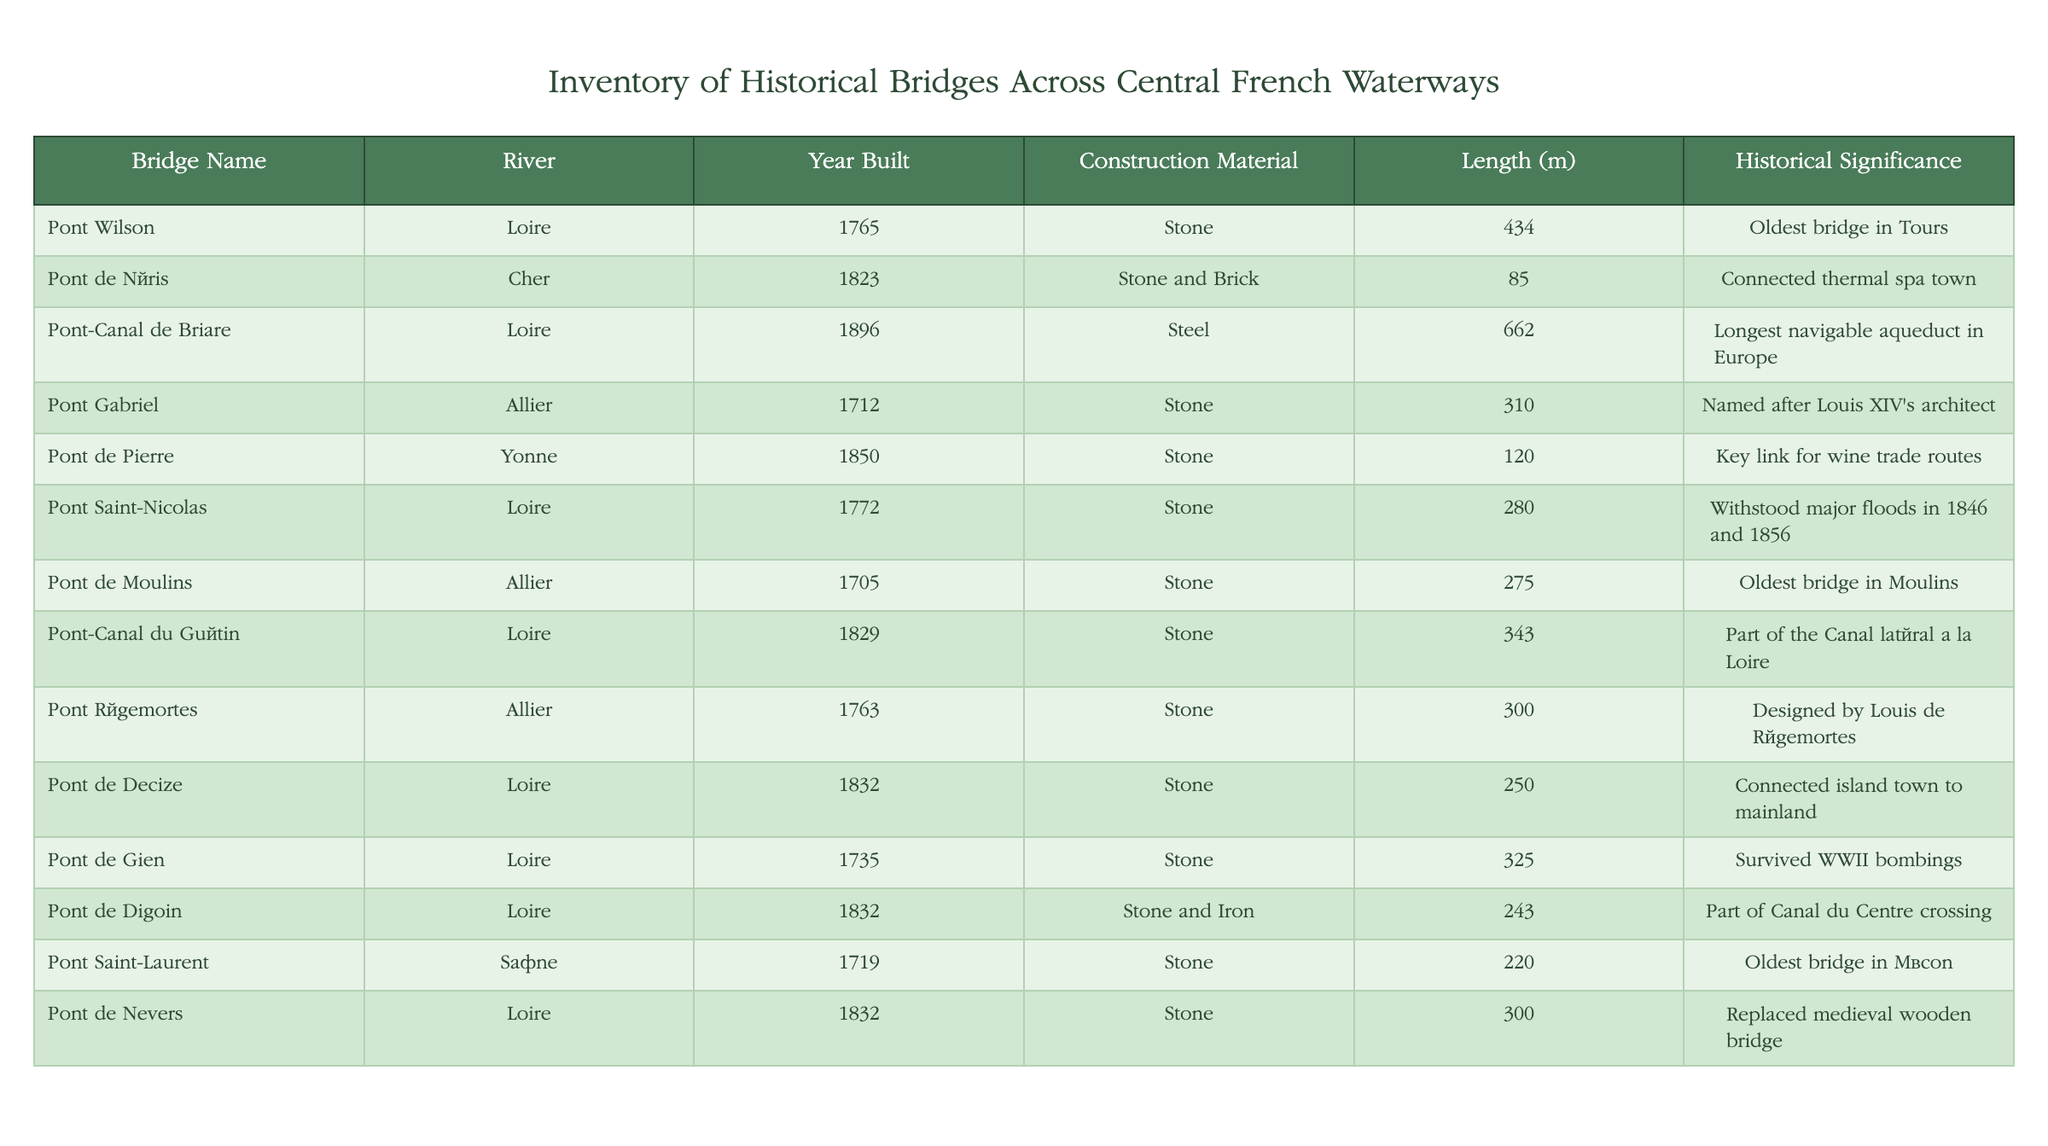What is the longest bridge listed in the inventory? The "Pont-Canal de Briare" is listed in the table with a length of 662 meters, which is the highest value among all bridges.
Answer: Pont-Canal de Briare Which bridge was built in the year 1829? The table shows that "Pont-Canal du Guétin" was constructed in 1829, specifically mentioned in the third column of the inventory.
Answer: Pont-Canal du Guétin Is there a bridge made of steel? The "Pont-Canal de Briare" is noted as being made of steel, confirming that there is indeed a bridge constructed with this material.
Answer: Yes What is the average length of the bridges that are made of stone? We gather the lengths of the stone bridges: 434, 85, 310, 275, 300, 325, 300 (total 1960), and divide by the number of stone bridges, which is 8. The average length is 1960/8 = 245 meters.
Answer: 245 How many bridges were built after 1800? The bridges built after 1800 are "Pont de Néris" (1823), "Pont-Canal du Guétin" (1829), "Pont de Decize" (1832), "Pont de Gien" (1735), "Pont de Digoin" (1832), and "Pont de Nevers" (1832). This results in 6 bridges in total.
Answer: 6 Which bridge was associated with wine trade routes? The table indicates that "Pont de Pierre" is specifically noted for being a key link for wine trade routes, as mentioned in the sixth column.
Answer: Pont de Pierre Did any bridges withstand major floods? Yes, "Pont Saint-Nicolas" is recorded for withstanding significant floods in the years 1846 and 1856.
Answer: Yes What is the year of the oldest bridge in Tours? According to the information, the "Pont Wilson," which is identified as the oldest bridge in Tours, was built in the year 1765.
Answer: 1765 